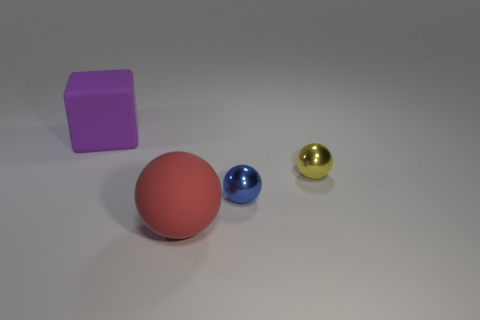Subtract all small blue spheres. How many spheres are left? 2 Subtract all red balls. How many balls are left? 2 Subtract 2 balls. How many balls are left? 1 Add 2 tiny cyan things. How many objects exist? 6 Subtract all purple cylinders. How many purple spheres are left? 0 Add 1 purple rubber objects. How many purple rubber objects exist? 2 Subtract 1 blue spheres. How many objects are left? 3 Subtract all balls. How many objects are left? 1 Subtract all blue spheres. Subtract all blue cylinders. How many spheres are left? 2 Subtract all purple objects. Subtract all large green metallic cylinders. How many objects are left? 3 